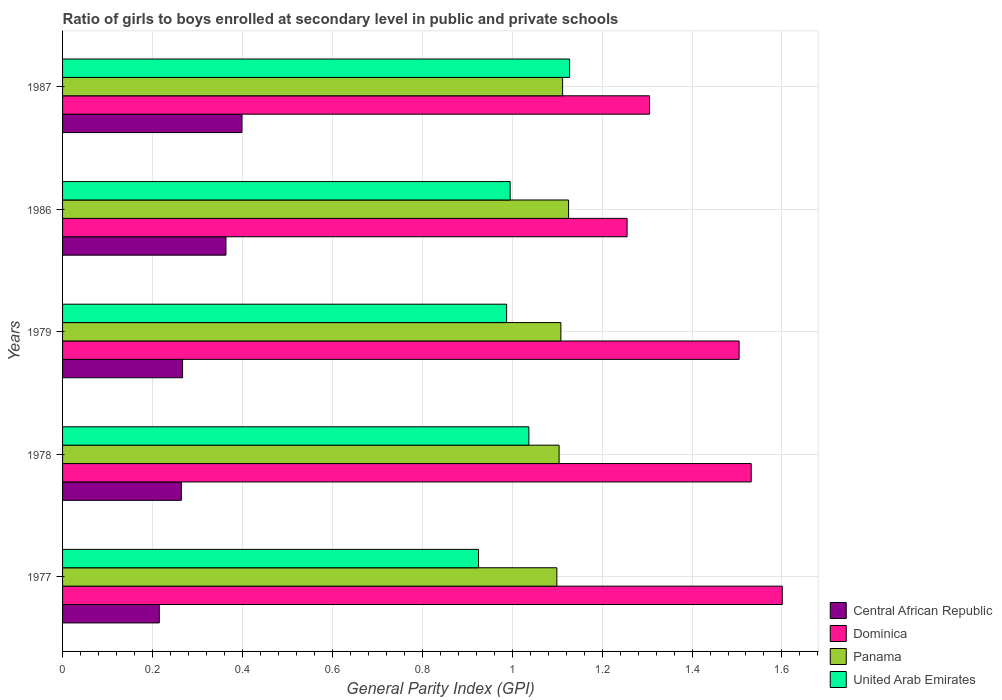Are the number of bars per tick equal to the number of legend labels?
Give a very brief answer. Yes. How many bars are there on the 5th tick from the top?
Your response must be concise. 4. How many bars are there on the 4th tick from the bottom?
Your answer should be very brief. 4. What is the label of the 3rd group of bars from the top?
Your response must be concise. 1979. In how many cases, is the number of bars for a given year not equal to the number of legend labels?
Ensure brevity in your answer.  0. What is the general parity index in Panama in 1979?
Provide a succinct answer. 1.11. Across all years, what is the maximum general parity index in Panama?
Give a very brief answer. 1.13. Across all years, what is the minimum general parity index in Panama?
Your response must be concise. 1.1. In which year was the general parity index in Panama minimum?
Offer a terse response. 1977. What is the total general parity index in Panama in the graph?
Your answer should be compact. 5.55. What is the difference between the general parity index in Dominica in 1977 and that in 1978?
Offer a very short reply. 0.07. What is the difference between the general parity index in United Arab Emirates in 1987 and the general parity index in Central African Republic in 1977?
Make the answer very short. 0.91. What is the average general parity index in Panama per year?
Offer a terse response. 1.11. In the year 1978, what is the difference between the general parity index in United Arab Emirates and general parity index in Dominica?
Give a very brief answer. -0.49. What is the ratio of the general parity index in Dominica in 1978 to that in 1986?
Give a very brief answer. 1.22. Is the general parity index in Central African Republic in 1979 less than that in 1986?
Offer a terse response. Yes. What is the difference between the highest and the second highest general parity index in Dominica?
Keep it short and to the point. 0.07. What is the difference between the highest and the lowest general parity index in Central African Republic?
Keep it short and to the point. 0.18. In how many years, is the general parity index in Panama greater than the average general parity index in Panama taken over all years?
Ensure brevity in your answer.  2. What does the 3rd bar from the top in 1979 represents?
Your answer should be compact. Dominica. What does the 1st bar from the bottom in 1977 represents?
Your answer should be compact. Central African Republic. Is it the case that in every year, the sum of the general parity index in Panama and general parity index in Dominica is greater than the general parity index in United Arab Emirates?
Make the answer very short. Yes. How many years are there in the graph?
Your answer should be compact. 5. What is the difference between two consecutive major ticks on the X-axis?
Provide a short and direct response. 0.2. Are the values on the major ticks of X-axis written in scientific E-notation?
Provide a succinct answer. No. How many legend labels are there?
Offer a very short reply. 4. What is the title of the graph?
Provide a succinct answer. Ratio of girls to boys enrolled at secondary level in public and private schools. Does "Senegal" appear as one of the legend labels in the graph?
Keep it short and to the point. No. What is the label or title of the X-axis?
Offer a terse response. General Parity Index (GPI). What is the General Parity Index (GPI) of Central African Republic in 1977?
Offer a terse response. 0.22. What is the General Parity Index (GPI) in Dominica in 1977?
Your response must be concise. 1.6. What is the General Parity Index (GPI) in Panama in 1977?
Keep it short and to the point. 1.1. What is the General Parity Index (GPI) in United Arab Emirates in 1977?
Make the answer very short. 0.93. What is the General Parity Index (GPI) of Central African Republic in 1978?
Provide a short and direct response. 0.26. What is the General Parity Index (GPI) in Dominica in 1978?
Keep it short and to the point. 1.53. What is the General Parity Index (GPI) of Panama in 1978?
Your answer should be very brief. 1.1. What is the General Parity Index (GPI) of United Arab Emirates in 1978?
Your response must be concise. 1.04. What is the General Parity Index (GPI) of Central African Republic in 1979?
Keep it short and to the point. 0.27. What is the General Parity Index (GPI) of Dominica in 1979?
Your answer should be very brief. 1.5. What is the General Parity Index (GPI) in Panama in 1979?
Your answer should be compact. 1.11. What is the General Parity Index (GPI) in United Arab Emirates in 1979?
Offer a terse response. 0.99. What is the General Parity Index (GPI) of Central African Republic in 1986?
Keep it short and to the point. 0.36. What is the General Parity Index (GPI) of Dominica in 1986?
Provide a short and direct response. 1.26. What is the General Parity Index (GPI) of Panama in 1986?
Make the answer very short. 1.13. What is the General Parity Index (GPI) of United Arab Emirates in 1986?
Give a very brief answer. 1. What is the General Parity Index (GPI) in Central African Republic in 1987?
Offer a very short reply. 0.4. What is the General Parity Index (GPI) of Dominica in 1987?
Provide a short and direct response. 1.31. What is the General Parity Index (GPI) of Panama in 1987?
Make the answer very short. 1.11. What is the General Parity Index (GPI) in United Arab Emirates in 1987?
Give a very brief answer. 1.13. Across all years, what is the maximum General Parity Index (GPI) of Central African Republic?
Offer a terse response. 0.4. Across all years, what is the maximum General Parity Index (GPI) in Dominica?
Give a very brief answer. 1.6. Across all years, what is the maximum General Parity Index (GPI) of Panama?
Give a very brief answer. 1.13. Across all years, what is the maximum General Parity Index (GPI) in United Arab Emirates?
Give a very brief answer. 1.13. Across all years, what is the minimum General Parity Index (GPI) of Central African Republic?
Your response must be concise. 0.22. Across all years, what is the minimum General Parity Index (GPI) in Dominica?
Make the answer very short. 1.26. Across all years, what is the minimum General Parity Index (GPI) in Panama?
Offer a terse response. 1.1. Across all years, what is the minimum General Parity Index (GPI) of United Arab Emirates?
Your response must be concise. 0.93. What is the total General Parity Index (GPI) in Central African Republic in the graph?
Ensure brevity in your answer.  1.51. What is the total General Parity Index (GPI) in Dominica in the graph?
Offer a very short reply. 7.2. What is the total General Parity Index (GPI) in Panama in the graph?
Offer a very short reply. 5.55. What is the total General Parity Index (GPI) in United Arab Emirates in the graph?
Give a very brief answer. 5.07. What is the difference between the General Parity Index (GPI) of Central African Republic in 1977 and that in 1978?
Offer a very short reply. -0.05. What is the difference between the General Parity Index (GPI) of Dominica in 1977 and that in 1978?
Give a very brief answer. 0.07. What is the difference between the General Parity Index (GPI) in Panama in 1977 and that in 1978?
Offer a terse response. -0.01. What is the difference between the General Parity Index (GPI) of United Arab Emirates in 1977 and that in 1978?
Keep it short and to the point. -0.11. What is the difference between the General Parity Index (GPI) of Central African Republic in 1977 and that in 1979?
Ensure brevity in your answer.  -0.05. What is the difference between the General Parity Index (GPI) in Dominica in 1977 and that in 1979?
Give a very brief answer. 0.1. What is the difference between the General Parity Index (GPI) in Panama in 1977 and that in 1979?
Give a very brief answer. -0.01. What is the difference between the General Parity Index (GPI) in United Arab Emirates in 1977 and that in 1979?
Your answer should be compact. -0.06. What is the difference between the General Parity Index (GPI) in Central African Republic in 1977 and that in 1986?
Provide a succinct answer. -0.15. What is the difference between the General Parity Index (GPI) in Dominica in 1977 and that in 1986?
Make the answer very short. 0.35. What is the difference between the General Parity Index (GPI) of Panama in 1977 and that in 1986?
Provide a succinct answer. -0.03. What is the difference between the General Parity Index (GPI) of United Arab Emirates in 1977 and that in 1986?
Offer a terse response. -0.07. What is the difference between the General Parity Index (GPI) in Central African Republic in 1977 and that in 1987?
Your response must be concise. -0.18. What is the difference between the General Parity Index (GPI) of Dominica in 1977 and that in 1987?
Provide a succinct answer. 0.3. What is the difference between the General Parity Index (GPI) of Panama in 1977 and that in 1987?
Your answer should be very brief. -0.01. What is the difference between the General Parity Index (GPI) of United Arab Emirates in 1977 and that in 1987?
Keep it short and to the point. -0.2. What is the difference between the General Parity Index (GPI) in Central African Republic in 1978 and that in 1979?
Provide a succinct answer. -0. What is the difference between the General Parity Index (GPI) of Dominica in 1978 and that in 1979?
Give a very brief answer. 0.03. What is the difference between the General Parity Index (GPI) of Panama in 1978 and that in 1979?
Keep it short and to the point. -0. What is the difference between the General Parity Index (GPI) in United Arab Emirates in 1978 and that in 1979?
Provide a short and direct response. 0.05. What is the difference between the General Parity Index (GPI) in Central African Republic in 1978 and that in 1986?
Offer a terse response. -0.1. What is the difference between the General Parity Index (GPI) of Dominica in 1978 and that in 1986?
Provide a succinct answer. 0.28. What is the difference between the General Parity Index (GPI) of Panama in 1978 and that in 1986?
Provide a succinct answer. -0.02. What is the difference between the General Parity Index (GPI) in United Arab Emirates in 1978 and that in 1986?
Offer a terse response. 0.04. What is the difference between the General Parity Index (GPI) of Central African Republic in 1978 and that in 1987?
Give a very brief answer. -0.13. What is the difference between the General Parity Index (GPI) of Dominica in 1978 and that in 1987?
Provide a succinct answer. 0.23. What is the difference between the General Parity Index (GPI) in Panama in 1978 and that in 1987?
Offer a very short reply. -0.01. What is the difference between the General Parity Index (GPI) in United Arab Emirates in 1978 and that in 1987?
Keep it short and to the point. -0.09. What is the difference between the General Parity Index (GPI) of Central African Republic in 1979 and that in 1986?
Ensure brevity in your answer.  -0.1. What is the difference between the General Parity Index (GPI) of Dominica in 1979 and that in 1986?
Offer a terse response. 0.25. What is the difference between the General Parity Index (GPI) in Panama in 1979 and that in 1986?
Keep it short and to the point. -0.02. What is the difference between the General Parity Index (GPI) in United Arab Emirates in 1979 and that in 1986?
Ensure brevity in your answer.  -0.01. What is the difference between the General Parity Index (GPI) of Central African Republic in 1979 and that in 1987?
Your response must be concise. -0.13. What is the difference between the General Parity Index (GPI) of Dominica in 1979 and that in 1987?
Give a very brief answer. 0.2. What is the difference between the General Parity Index (GPI) in Panama in 1979 and that in 1987?
Provide a succinct answer. -0. What is the difference between the General Parity Index (GPI) in United Arab Emirates in 1979 and that in 1987?
Ensure brevity in your answer.  -0.14. What is the difference between the General Parity Index (GPI) in Central African Republic in 1986 and that in 1987?
Keep it short and to the point. -0.04. What is the difference between the General Parity Index (GPI) of Panama in 1986 and that in 1987?
Ensure brevity in your answer.  0.01. What is the difference between the General Parity Index (GPI) of United Arab Emirates in 1986 and that in 1987?
Offer a very short reply. -0.13. What is the difference between the General Parity Index (GPI) of Central African Republic in 1977 and the General Parity Index (GPI) of Dominica in 1978?
Provide a succinct answer. -1.32. What is the difference between the General Parity Index (GPI) in Central African Republic in 1977 and the General Parity Index (GPI) in Panama in 1978?
Offer a terse response. -0.89. What is the difference between the General Parity Index (GPI) of Central African Republic in 1977 and the General Parity Index (GPI) of United Arab Emirates in 1978?
Keep it short and to the point. -0.82. What is the difference between the General Parity Index (GPI) of Dominica in 1977 and the General Parity Index (GPI) of Panama in 1978?
Your response must be concise. 0.5. What is the difference between the General Parity Index (GPI) in Dominica in 1977 and the General Parity Index (GPI) in United Arab Emirates in 1978?
Provide a short and direct response. 0.56. What is the difference between the General Parity Index (GPI) in Panama in 1977 and the General Parity Index (GPI) in United Arab Emirates in 1978?
Your response must be concise. 0.06. What is the difference between the General Parity Index (GPI) in Central African Republic in 1977 and the General Parity Index (GPI) in Dominica in 1979?
Make the answer very short. -1.29. What is the difference between the General Parity Index (GPI) of Central African Republic in 1977 and the General Parity Index (GPI) of Panama in 1979?
Provide a short and direct response. -0.89. What is the difference between the General Parity Index (GPI) of Central African Republic in 1977 and the General Parity Index (GPI) of United Arab Emirates in 1979?
Make the answer very short. -0.77. What is the difference between the General Parity Index (GPI) in Dominica in 1977 and the General Parity Index (GPI) in Panama in 1979?
Provide a short and direct response. 0.49. What is the difference between the General Parity Index (GPI) in Dominica in 1977 and the General Parity Index (GPI) in United Arab Emirates in 1979?
Your answer should be compact. 0.61. What is the difference between the General Parity Index (GPI) in Panama in 1977 and the General Parity Index (GPI) in United Arab Emirates in 1979?
Your response must be concise. 0.11. What is the difference between the General Parity Index (GPI) in Central African Republic in 1977 and the General Parity Index (GPI) in Dominica in 1986?
Keep it short and to the point. -1.04. What is the difference between the General Parity Index (GPI) of Central African Republic in 1977 and the General Parity Index (GPI) of Panama in 1986?
Keep it short and to the point. -0.91. What is the difference between the General Parity Index (GPI) of Central African Republic in 1977 and the General Parity Index (GPI) of United Arab Emirates in 1986?
Provide a succinct answer. -0.78. What is the difference between the General Parity Index (GPI) in Dominica in 1977 and the General Parity Index (GPI) in Panama in 1986?
Give a very brief answer. 0.48. What is the difference between the General Parity Index (GPI) of Dominica in 1977 and the General Parity Index (GPI) of United Arab Emirates in 1986?
Keep it short and to the point. 0.61. What is the difference between the General Parity Index (GPI) of Panama in 1977 and the General Parity Index (GPI) of United Arab Emirates in 1986?
Your answer should be compact. 0.1. What is the difference between the General Parity Index (GPI) in Central African Republic in 1977 and the General Parity Index (GPI) in Dominica in 1987?
Offer a very short reply. -1.09. What is the difference between the General Parity Index (GPI) of Central African Republic in 1977 and the General Parity Index (GPI) of Panama in 1987?
Your answer should be very brief. -0.9. What is the difference between the General Parity Index (GPI) of Central African Republic in 1977 and the General Parity Index (GPI) of United Arab Emirates in 1987?
Your answer should be compact. -0.91. What is the difference between the General Parity Index (GPI) in Dominica in 1977 and the General Parity Index (GPI) in Panama in 1987?
Provide a short and direct response. 0.49. What is the difference between the General Parity Index (GPI) in Dominica in 1977 and the General Parity Index (GPI) in United Arab Emirates in 1987?
Provide a short and direct response. 0.47. What is the difference between the General Parity Index (GPI) of Panama in 1977 and the General Parity Index (GPI) of United Arab Emirates in 1987?
Offer a terse response. -0.03. What is the difference between the General Parity Index (GPI) in Central African Republic in 1978 and the General Parity Index (GPI) in Dominica in 1979?
Make the answer very short. -1.24. What is the difference between the General Parity Index (GPI) of Central African Republic in 1978 and the General Parity Index (GPI) of Panama in 1979?
Make the answer very short. -0.84. What is the difference between the General Parity Index (GPI) of Central African Republic in 1978 and the General Parity Index (GPI) of United Arab Emirates in 1979?
Ensure brevity in your answer.  -0.72. What is the difference between the General Parity Index (GPI) of Dominica in 1978 and the General Parity Index (GPI) of Panama in 1979?
Ensure brevity in your answer.  0.42. What is the difference between the General Parity Index (GPI) in Dominica in 1978 and the General Parity Index (GPI) in United Arab Emirates in 1979?
Your answer should be very brief. 0.54. What is the difference between the General Parity Index (GPI) of Panama in 1978 and the General Parity Index (GPI) of United Arab Emirates in 1979?
Make the answer very short. 0.12. What is the difference between the General Parity Index (GPI) in Central African Republic in 1978 and the General Parity Index (GPI) in Dominica in 1986?
Your answer should be very brief. -0.99. What is the difference between the General Parity Index (GPI) in Central African Republic in 1978 and the General Parity Index (GPI) in Panama in 1986?
Your answer should be compact. -0.86. What is the difference between the General Parity Index (GPI) of Central African Republic in 1978 and the General Parity Index (GPI) of United Arab Emirates in 1986?
Provide a short and direct response. -0.73. What is the difference between the General Parity Index (GPI) of Dominica in 1978 and the General Parity Index (GPI) of Panama in 1986?
Provide a short and direct response. 0.41. What is the difference between the General Parity Index (GPI) of Dominica in 1978 and the General Parity Index (GPI) of United Arab Emirates in 1986?
Provide a short and direct response. 0.54. What is the difference between the General Parity Index (GPI) of Panama in 1978 and the General Parity Index (GPI) of United Arab Emirates in 1986?
Give a very brief answer. 0.11. What is the difference between the General Parity Index (GPI) of Central African Republic in 1978 and the General Parity Index (GPI) of Dominica in 1987?
Your answer should be compact. -1.04. What is the difference between the General Parity Index (GPI) of Central African Republic in 1978 and the General Parity Index (GPI) of Panama in 1987?
Provide a short and direct response. -0.85. What is the difference between the General Parity Index (GPI) in Central African Republic in 1978 and the General Parity Index (GPI) in United Arab Emirates in 1987?
Keep it short and to the point. -0.86. What is the difference between the General Parity Index (GPI) in Dominica in 1978 and the General Parity Index (GPI) in Panama in 1987?
Offer a very short reply. 0.42. What is the difference between the General Parity Index (GPI) in Dominica in 1978 and the General Parity Index (GPI) in United Arab Emirates in 1987?
Your answer should be compact. 0.4. What is the difference between the General Parity Index (GPI) in Panama in 1978 and the General Parity Index (GPI) in United Arab Emirates in 1987?
Your answer should be very brief. -0.02. What is the difference between the General Parity Index (GPI) in Central African Republic in 1979 and the General Parity Index (GPI) in Dominica in 1986?
Keep it short and to the point. -0.99. What is the difference between the General Parity Index (GPI) of Central African Republic in 1979 and the General Parity Index (GPI) of Panama in 1986?
Your answer should be very brief. -0.86. What is the difference between the General Parity Index (GPI) of Central African Republic in 1979 and the General Parity Index (GPI) of United Arab Emirates in 1986?
Provide a short and direct response. -0.73. What is the difference between the General Parity Index (GPI) in Dominica in 1979 and the General Parity Index (GPI) in Panama in 1986?
Offer a very short reply. 0.38. What is the difference between the General Parity Index (GPI) of Dominica in 1979 and the General Parity Index (GPI) of United Arab Emirates in 1986?
Make the answer very short. 0.51. What is the difference between the General Parity Index (GPI) in Panama in 1979 and the General Parity Index (GPI) in United Arab Emirates in 1986?
Your answer should be compact. 0.11. What is the difference between the General Parity Index (GPI) in Central African Republic in 1979 and the General Parity Index (GPI) in Dominica in 1987?
Provide a succinct answer. -1.04. What is the difference between the General Parity Index (GPI) of Central African Republic in 1979 and the General Parity Index (GPI) of Panama in 1987?
Offer a terse response. -0.85. What is the difference between the General Parity Index (GPI) of Central African Republic in 1979 and the General Parity Index (GPI) of United Arab Emirates in 1987?
Your answer should be very brief. -0.86. What is the difference between the General Parity Index (GPI) of Dominica in 1979 and the General Parity Index (GPI) of Panama in 1987?
Your response must be concise. 0.39. What is the difference between the General Parity Index (GPI) in Dominica in 1979 and the General Parity Index (GPI) in United Arab Emirates in 1987?
Your answer should be compact. 0.38. What is the difference between the General Parity Index (GPI) of Panama in 1979 and the General Parity Index (GPI) of United Arab Emirates in 1987?
Provide a succinct answer. -0.02. What is the difference between the General Parity Index (GPI) in Central African Republic in 1986 and the General Parity Index (GPI) in Dominica in 1987?
Your answer should be very brief. -0.94. What is the difference between the General Parity Index (GPI) of Central African Republic in 1986 and the General Parity Index (GPI) of Panama in 1987?
Offer a very short reply. -0.75. What is the difference between the General Parity Index (GPI) in Central African Republic in 1986 and the General Parity Index (GPI) in United Arab Emirates in 1987?
Provide a succinct answer. -0.76. What is the difference between the General Parity Index (GPI) in Dominica in 1986 and the General Parity Index (GPI) in Panama in 1987?
Make the answer very short. 0.14. What is the difference between the General Parity Index (GPI) in Dominica in 1986 and the General Parity Index (GPI) in United Arab Emirates in 1987?
Make the answer very short. 0.13. What is the difference between the General Parity Index (GPI) in Panama in 1986 and the General Parity Index (GPI) in United Arab Emirates in 1987?
Make the answer very short. -0. What is the average General Parity Index (GPI) in Central African Republic per year?
Offer a terse response. 0.3. What is the average General Parity Index (GPI) of Dominica per year?
Provide a short and direct response. 1.44. What is the average General Parity Index (GPI) in Panama per year?
Your answer should be compact. 1.11. What is the average General Parity Index (GPI) of United Arab Emirates per year?
Make the answer very short. 1.01. In the year 1977, what is the difference between the General Parity Index (GPI) in Central African Republic and General Parity Index (GPI) in Dominica?
Offer a terse response. -1.39. In the year 1977, what is the difference between the General Parity Index (GPI) of Central African Republic and General Parity Index (GPI) of Panama?
Provide a succinct answer. -0.88. In the year 1977, what is the difference between the General Parity Index (GPI) in Central African Republic and General Parity Index (GPI) in United Arab Emirates?
Your answer should be very brief. -0.71. In the year 1977, what is the difference between the General Parity Index (GPI) of Dominica and General Parity Index (GPI) of Panama?
Keep it short and to the point. 0.5. In the year 1977, what is the difference between the General Parity Index (GPI) in Dominica and General Parity Index (GPI) in United Arab Emirates?
Offer a very short reply. 0.68. In the year 1977, what is the difference between the General Parity Index (GPI) in Panama and General Parity Index (GPI) in United Arab Emirates?
Your answer should be very brief. 0.17. In the year 1978, what is the difference between the General Parity Index (GPI) in Central African Republic and General Parity Index (GPI) in Dominica?
Offer a very short reply. -1.27. In the year 1978, what is the difference between the General Parity Index (GPI) of Central African Republic and General Parity Index (GPI) of Panama?
Make the answer very short. -0.84. In the year 1978, what is the difference between the General Parity Index (GPI) in Central African Republic and General Parity Index (GPI) in United Arab Emirates?
Your response must be concise. -0.77. In the year 1978, what is the difference between the General Parity Index (GPI) in Dominica and General Parity Index (GPI) in Panama?
Keep it short and to the point. 0.43. In the year 1978, what is the difference between the General Parity Index (GPI) in Dominica and General Parity Index (GPI) in United Arab Emirates?
Give a very brief answer. 0.49. In the year 1978, what is the difference between the General Parity Index (GPI) of Panama and General Parity Index (GPI) of United Arab Emirates?
Offer a terse response. 0.07. In the year 1979, what is the difference between the General Parity Index (GPI) of Central African Republic and General Parity Index (GPI) of Dominica?
Provide a short and direct response. -1.24. In the year 1979, what is the difference between the General Parity Index (GPI) in Central African Republic and General Parity Index (GPI) in Panama?
Give a very brief answer. -0.84. In the year 1979, what is the difference between the General Parity Index (GPI) of Central African Republic and General Parity Index (GPI) of United Arab Emirates?
Your answer should be very brief. -0.72. In the year 1979, what is the difference between the General Parity Index (GPI) of Dominica and General Parity Index (GPI) of Panama?
Provide a succinct answer. 0.4. In the year 1979, what is the difference between the General Parity Index (GPI) in Dominica and General Parity Index (GPI) in United Arab Emirates?
Provide a short and direct response. 0.52. In the year 1979, what is the difference between the General Parity Index (GPI) of Panama and General Parity Index (GPI) of United Arab Emirates?
Make the answer very short. 0.12. In the year 1986, what is the difference between the General Parity Index (GPI) of Central African Republic and General Parity Index (GPI) of Dominica?
Keep it short and to the point. -0.89. In the year 1986, what is the difference between the General Parity Index (GPI) in Central African Republic and General Parity Index (GPI) in Panama?
Offer a very short reply. -0.76. In the year 1986, what is the difference between the General Parity Index (GPI) of Central African Republic and General Parity Index (GPI) of United Arab Emirates?
Offer a very short reply. -0.63. In the year 1986, what is the difference between the General Parity Index (GPI) in Dominica and General Parity Index (GPI) in Panama?
Your answer should be compact. 0.13. In the year 1986, what is the difference between the General Parity Index (GPI) in Dominica and General Parity Index (GPI) in United Arab Emirates?
Keep it short and to the point. 0.26. In the year 1986, what is the difference between the General Parity Index (GPI) in Panama and General Parity Index (GPI) in United Arab Emirates?
Make the answer very short. 0.13. In the year 1987, what is the difference between the General Parity Index (GPI) in Central African Republic and General Parity Index (GPI) in Dominica?
Give a very brief answer. -0.91. In the year 1987, what is the difference between the General Parity Index (GPI) in Central African Republic and General Parity Index (GPI) in Panama?
Offer a very short reply. -0.71. In the year 1987, what is the difference between the General Parity Index (GPI) of Central African Republic and General Parity Index (GPI) of United Arab Emirates?
Your answer should be very brief. -0.73. In the year 1987, what is the difference between the General Parity Index (GPI) in Dominica and General Parity Index (GPI) in Panama?
Provide a succinct answer. 0.19. In the year 1987, what is the difference between the General Parity Index (GPI) of Dominica and General Parity Index (GPI) of United Arab Emirates?
Your answer should be compact. 0.18. In the year 1987, what is the difference between the General Parity Index (GPI) in Panama and General Parity Index (GPI) in United Arab Emirates?
Give a very brief answer. -0.02. What is the ratio of the General Parity Index (GPI) in Central African Republic in 1977 to that in 1978?
Provide a short and direct response. 0.81. What is the ratio of the General Parity Index (GPI) in Dominica in 1977 to that in 1978?
Offer a very short reply. 1.05. What is the ratio of the General Parity Index (GPI) in Panama in 1977 to that in 1978?
Make the answer very short. 1. What is the ratio of the General Parity Index (GPI) of United Arab Emirates in 1977 to that in 1978?
Provide a succinct answer. 0.89. What is the ratio of the General Parity Index (GPI) in Central African Republic in 1977 to that in 1979?
Your answer should be very brief. 0.81. What is the ratio of the General Parity Index (GPI) in Dominica in 1977 to that in 1979?
Your answer should be very brief. 1.06. What is the ratio of the General Parity Index (GPI) in Panama in 1977 to that in 1979?
Offer a very short reply. 0.99. What is the ratio of the General Parity Index (GPI) of United Arab Emirates in 1977 to that in 1979?
Provide a short and direct response. 0.94. What is the ratio of the General Parity Index (GPI) of Central African Republic in 1977 to that in 1986?
Provide a succinct answer. 0.59. What is the ratio of the General Parity Index (GPI) in Dominica in 1977 to that in 1986?
Provide a succinct answer. 1.27. What is the ratio of the General Parity Index (GPI) in Panama in 1977 to that in 1986?
Offer a terse response. 0.98. What is the ratio of the General Parity Index (GPI) in United Arab Emirates in 1977 to that in 1986?
Give a very brief answer. 0.93. What is the ratio of the General Parity Index (GPI) of Central African Republic in 1977 to that in 1987?
Offer a very short reply. 0.54. What is the ratio of the General Parity Index (GPI) of Dominica in 1977 to that in 1987?
Provide a short and direct response. 1.23. What is the ratio of the General Parity Index (GPI) in Panama in 1977 to that in 1987?
Ensure brevity in your answer.  0.99. What is the ratio of the General Parity Index (GPI) of United Arab Emirates in 1977 to that in 1987?
Ensure brevity in your answer.  0.82. What is the ratio of the General Parity Index (GPI) of Central African Republic in 1978 to that in 1979?
Provide a succinct answer. 0.99. What is the ratio of the General Parity Index (GPI) in Dominica in 1978 to that in 1979?
Ensure brevity in your answer.  1.02. What is the ratio of the General Parity Index (GPI) of Central African Republic in 1978 to that in 1986?
Offer a very short reply. 0.73. What is the ratio of the General Parity Index (GPI) in Dominica in 1978 to that in 1986?
Your response must be concise. 1.22. What is the ratio of the General Parity Index (GPI) in Panama in 1978 to that in 1986?
Make the answer very short. 0.98. What is the ratio of the General Parity Index (GPI) of United Arab Emirates in 1978 to that in 1986?
Offer a terse response. 1.04. What is the ratio of the General Parity Index (GPI) of Central African Republic in 1978 to that in 1987?
Give a very brief answer. 0.66. What is the ratio of the General Parity Index (GPI) in Dominica in 1978 to that in 1987?
Your response must be concise. 1.17. What is the ratio of the General Parity Index (GPI) in Panama in 1978 to that in 1987?
Your answer should be very brief. 0.99. What is the ratio of the General Parity Index (GPI) of United Arab Emirates in 1978 to that in 1987?
Your response must be concise. 0.92. What is the ratio of the General Parity Index (GPI) of Central African Republic in 1979 to that in 1986?
Your answer should be compact. 0.73. What is the ratio of the General Parity Index (GPI) of Dominica in 1979 to that in 1986?
Ensure brevity in your answer.  1.2. What is the ratio of the General Parity Index (GPI) of Panama in 1979 to that in 1986?
Your response must be concise. 0.98. What is the ratio of the General Parity Index (GPI) of Central African Republic in 1979 to that in 1987?
Offer a terse response. 0.67. What is the ratio of the General Parity Index (GPI) in Dominica in 1979 to that in 1987?
Your answer should be compact. 1.15. What is the ratio of the General Parity Index (GPI) of United Arab Emirates in 1979 to that in 1987?
Keep it short and to the point. 0.88. What is the ratio of the General Parity Index (GPI) in Central African Republic in 1986 to that in 1987?
Ensure brevity in your answer.  0.91. What is the ratio of the General Parity Index (GPI) in Dominica in 1986 to that in 1987?
Your answer should be compact. 0.96. What is the ratio of the General Parity Index (GPI) of United Arab Emirates in 1986 to that in 1987?
Give a very brief answer. 0.88. What is the difference between the highest and the second highest General Parity Index (GPI) of Central African Republic?
Your answer should be very brief. 0.04. What is the difference between the highest and the second highest General Parity Index (GPI) of Dominica?
Provide a succinct answer. 0.07. What is the difference between the highest and the second highest General Parity Index (GPI) of Panama?
Make the answer very short. 0.01. What is the difference between the highest and the second highest General Parity Index (GPI) in United Arab Emirates?
Your response must be concise. 0.09. What is the difference between the highest and the lowest General Parity Index (GPI) in Central African Republic?
Your response must be concise. 0.18. What is the difference between the highest and the lowest General Parity Index (GPI) of Dominica?
Give a very brief answer. 0.35. What is the difference between the highest and the lowest General Parity Index (GPI) of Panama?
Make the answer very short. 0.03. What is the difference between the highest and the lowest General Parity Index (GPI) of United Arab Emirates?
Offer a very short reply. 0.2. 